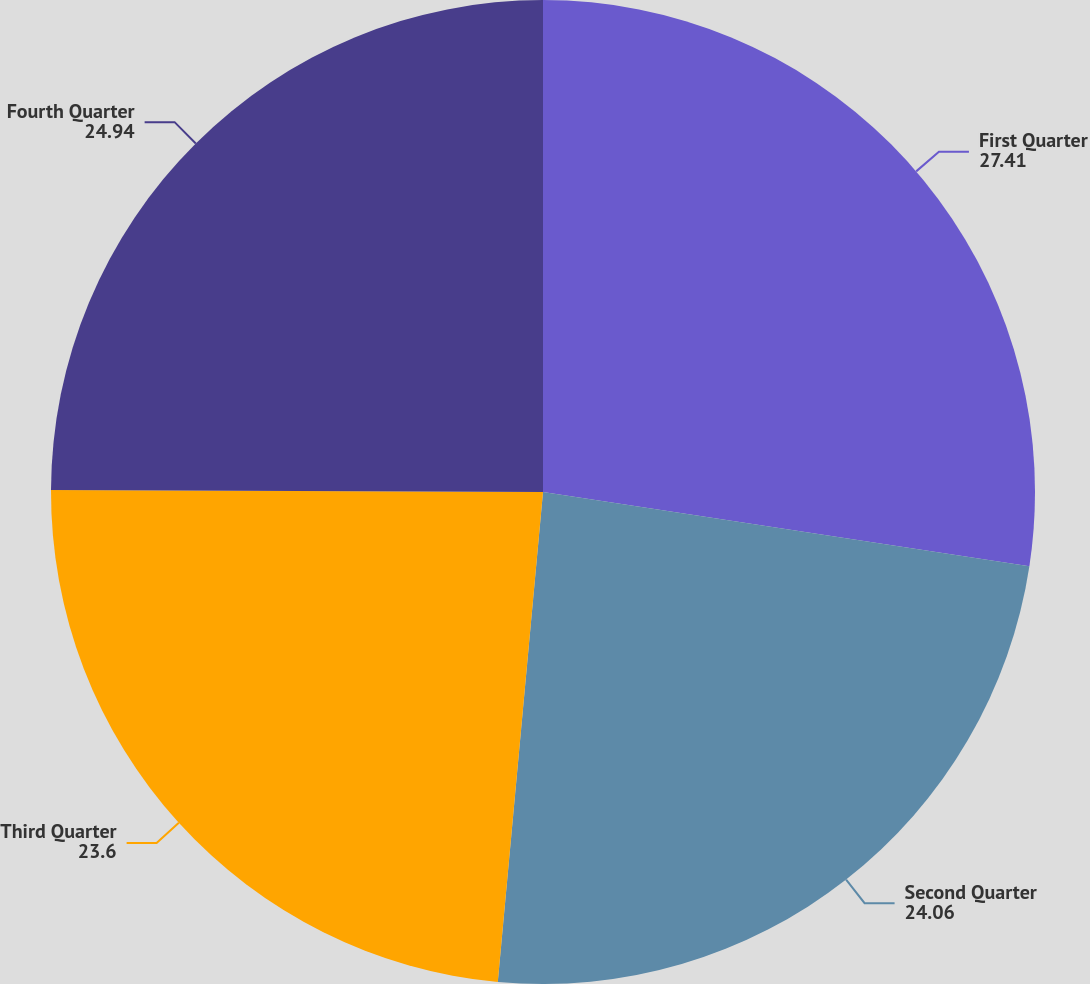<chart> <loc_0><loc_0><loc_500><loc_500><pie_chart><fcel>First Quarter<fcel>Second Quarter<fcel>Third Quarter<fcel>Fourth Quarter<nl><fcel>27.41%<fcel>24.06%<fcel>23.6%<fcel>24.94%<nl></chart> 